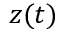<formula> <loc_0><loc_0><loc_500><loc_500>z ( t )</formula> 